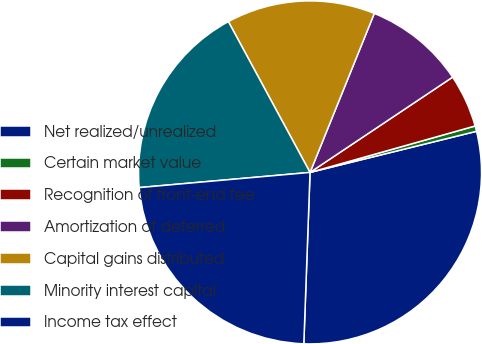Convert chart to OTSL. <chart><loc_0><loc_0><loc_500><loc_500><pie_chart><fcel>Net realized/unrealized<fcel>Certain market value<fcel>Recognition of front-end fee<fcel>Amortization of deferred<fcel>Capital gains distributed<fcel>Minority interest capital<fcel>Income tax effect<nl><fcel>29.43%<fcel>0.51%<fcel>5.01%<fcel>9.51%<fcel>14.01%<fcel>18.51%<fcel>23.01%<nl></chart> 